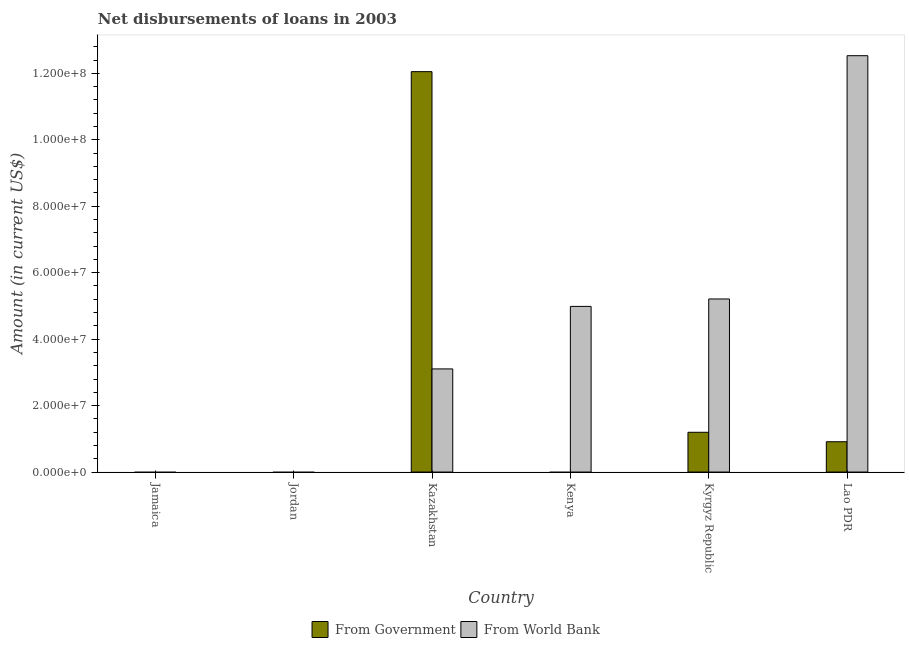Are the number of bars on each tick of the X-axis equal?
Your answer should be very brief. No. How many bars are there on the 3rd tick from the left?
Offer a terse response. 2. What is the label of the 2nd group of bars from the left?
Your response must be concise. Jordan. What is the net disbursements of loan from world bank in Jordan?
Your answer should be very brief. 0. Across all countries, what is the maximum net disbursements of loan from world bank?
Provide a succinct answer. 1.25e+08. Across all countries, what is the minimum net disbursements of loan from world bank?
Keep it short and to the point. 0. In which country was the net disbursements of loan from government maximum?
Make the answer very short. Kazakhstan. What is the total net disbursements of loan from government in the graph?
Your response must be concise. 1.42e+08. What is the difference between the net disbursements of loan from world bank in Kazakhstan and that in Kyrgyz Republic?
Give a very brief answer. -2.11e+07. What is the difference between the net disbursements of loan from government in Kazakhstan and the net disbursements of loan from world bank in Jamaica?
Ensure brevity in your answer.  1.21e+08. What is the average net disbursements of loan from government per country?
Your response must be concise. 2.36e+07. What is the difference between the net disbursements of loan from world bank and net disbursements of loan from government in Kyrgyz Republic?
Provide a short and direct response. 4.01e+07. What is the ratio of the net disbursements of loan from world bank in Kyrgyz Republic to that in Lao PDR?
Offer a terse response. 0.42. What is the difference between the highest and the second highest net disbursements of loan from government?
Keep it short and to the point. 1.09e+08. What is the difference between the highest and the lowest net disbursements of loan from government?
Offer a very short reply. 1.21e+08. Are all the bars in the graph horizontal?
Your response must be concise. No. What is the difference between two consecutive major ticks on the Y-axis?
Your answer should be very brief. 2.00e+07. Are the values on the major ticks of Y-axis written in scientific E-notation?
Keep it short and to the point. Yes. Does the graph contain any zero values?
Your answer should be compact. Yes. How many legend labels are there?
Give a very brief answer. 2. How are the legend labels stacked?
Ensure brevity in your answer.  Horizontal. What is the title of the graph?
Your response must be concise. Net disbursements of loans in 2003. What is the Amount (in current US$) in From Government in Jamaica?
Offer a terse response. 0. What is the Amount (in current US$) of From World Bank in Jordan?
Keep it short and to the point. 0. What is the Amount (in current US$) in From Government in Kazakhstan?
Keep it short and to the point. 1.21e+08. What is the Amount (in current US$) in From World Bank in Kazakhstan?
Ensure brevity in your answer.  3.10e+07. What is the Amount (in current US$) of From Government in Kenya?
Your answer should be compact. 0. What is the Amount (in current US$) in From World Bank in Kenya?
Make the answer very short. 4.99e+07. What is the Amount (in current US$) in From Government in Kyrgyz Republic?
Offer a very short reply. 1.20e+07. What is the Amount (in current US$) of From World Bank in Kyrgyz Republic?
Give a very brief answer. 5.21e+07. What is the Amount (in current US$) in From Government in Lao PDR?
Your answer should be compact. 9.12e+06. What is the Amount (in current US$) of From World Bank in Lao PDR?
Give a very brief answer. 1.25e+08. Across all countries, what is the maximum Amount (in current US$) in From Government?
Make the answer very short. 1.21e+08. Across all countries, what is the maximum Amount (in current US$) in From World Bank?
Offer a terse response. 1.25e+08. Across all countries, what is the minimum Amount (in current US$) of From World Bank?
Offer a terse response. 0. What is the total Amount (in current US$) in From Government in the graph?
Offer a very short reply. 1.42e+08. What is the total Amount (in current US$) in From World Bank in the graph?
Your answer should be compact. 2.58e+08. What is the difference between the Amount (in current US$) of From World Bank in Kazakhstan and that in Kenya?
Keep it short and to the point. -1.88e+07. What is the difference between the Amount (in current US$) of From Government in Kazakhstan and that in Kyrgyz Republic?
Your response must be concise. 1.09e+08. What is the difference between the Amount (in current US$) in From World Bank in Kazakhstan and that in Kyrgyz Republic?
Provide a short and direct response. -2.11e+07. What is the difference between the Amount (in current US$) of From Government in Kazakhstan and that in Lao PDR?
Your answer should be very brief. 1.11e+08. What is the difference between the Amount (in current US$) of From World Bank in Kazakhstan and that in Lao PDR?
Keep it short and to the point. -9.43e+07. What is the difference between the Amount (in current US$) in From World Bank in Kenya and that in Kyrgyz Republic?
Provide a succinct answer. -2.24e+06. What is the difference between the Amount (in current US$) of From World Bank in Kenya and that in Lao PDR?
Offer a very short reply. -7.55e+07. What is the difference between the Amount (in current US$) in From Government in Kyrgyz Republic and that in Lao PDR?
Provide a succinct answer. 2.85e+06. What is the difference between the Amount (in current US$) of From World Bank in Kyrgyz Republic and that in Lao PDR?
Give a very brief answer. -7.32e+07. What is the difference between the Amount (in current US$) in From Government in Kazakhstan and the Amount (in current US$) in From World Bank in Kenya?
Make the answer very short. 7.07e+07. What is the difference between the Amount (in current US$) of From Government in Kazakhstan and the Amount (in current US$) of From World Bank in Kyrgyz Republic?
Provide a succinct answer. 6.84e+07. What is the difference between the Amount (in current US$) of From Government in Kazakhstan and the Amount (in current US$) of From World Bank in Lao PDR?
Ensure brevity in your answer.  -4.80e+06. What is the difference between the Amount (in current US$) of From Government in Kyrgyz Republic and the Amount (in current US$) of From World Bank in Lao PDR?
Offer a very short reply. -1.13e+08. What is the average Amount (in current US$) of From Government per country?
Keep it short and to the point. 2.36e+07. What is the average Amount (in current US$) in From World Bank per country?
Your answer should be very brief. 4.31e+07. What is the difference between the Amount (in current US$) in From Government and Amount (in current US$) in From World Bank in Kazakhstan?
Provide a succinct answer. 8.95e+07. What is the difference between the Amount (in current US$) in From Government and Amount (in current US$) in From World Bank in Kyrgyz Republic?
Ensure brevity in your answer.  -4.01e+07. What is the difference between the Amount (in current US$) of From Government and Amount (in current US$) of From World Bank in Lao PDR?
Your response must be concise. -1.16e+08. What is the ratio of the Amount (in current US$) in From World Bank in Kazakhstan to that in Kenya?
Ensure brevity in your answer.  0.62. What is the ratio of the Amount (in current US$) in From Government in Kazakhstan to that in Kyrgyz Republic?
Keep it short and to the point. 10.07. What is the ratio of the Amount (in current US$) in From World Bank in Kazakhstan to that in Kyrgyz Republic?
Provide a succinct answer. 0.6. What is the ratio of the Amount (in current US$) of From Government in Kazakhstan to that in Lao PDR?
Your response must be concise. 13.22. What is the ratio of the Amount (in current US$) of From World Bank in Kazakhstan to that in Lao PDR?
Offer a very short reply. 0.25. What is the ratio of the Amount (in current US$) in From World Bank in Kenya to that in Lao PDR?
Keep it short and to the point. 0.4. What is the ratio of the Amount (in current US$) of From Government in Kyrgyz Republic to that in Lao PDR?
Provide a succinct answer. 1.31. What is the ratio of the Amount (in current US$) in From World Bank in Kyrgyz Republic to that in Lao PDR?
Ensure brevity in your answer.  0.42. What is the difference between the highest and the second highest Amount (in current US$) of From Government?
Offer a terse response. 1.09e+08. What is the difference between the highest and the second highest Amount (in current US$) of From World Bank?
Provide a succinct answer. 7.32e+07. What is the difference between the highest and the lowest Amount (in current US$) of From Government?
Provide a short and direct response. 1.21e+08. What is the difference between the highest and the lowest Amount (in current US$) in From World Bank?
Provide a short and direct response. 1.25e+08. 